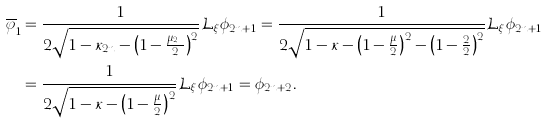Convert formula to latex. <formula><loc_0><loc_0><loc_500><loc_500>\overline { \varphi } _ { 1 } & = \frac { 1 } { 2 \sqrt { 1 - \kappa _ { 2 n } - \left ( 1 - \frac { \mu _ { 2 n } } { 2 } \right ) ^ { 2 } } } { \mathcal { L } } _ { \xi } \phi _ { 2 n + 1 } = \frac { 1 } { 2 \sqrt { 1 - \kappa - \left ( 1 - \frac { \mu } { 2 } \right ) ^ { 2 } - \left ( 1 - \frac { 2 } { 2 } \right ) ^ { 2 } } } { \mathcal { L } } _ { \xi } \phi _ { 2 n + 1 } \\ & = \frac { 1 } { 2 \sqrt { 1 - \kappa - \left ( 1 - \frac { \mu } { 2 } \right ) ^ { 2 } } } { \mathcal { L } } _ { \xi } \phi _ { 2 n + 1 } = \phi _ { 2 n + 2 } .</formula> 